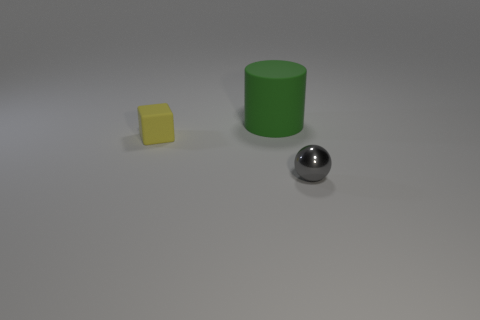Add 2 tiny yellow matte objects. How many objects exist? 5 Subtract all spheres. How many objects are left? 2 Subtract 0 gray blocks. How many objects are left? 3 Subtract all green matte cylinders. Subtract all small spheres. How many objects are left? 1 Add 1 tiny yellow objects. How many tiny yellow objects are left? 2 Add 3 big rubber things. How many big rubber things exist? 4 